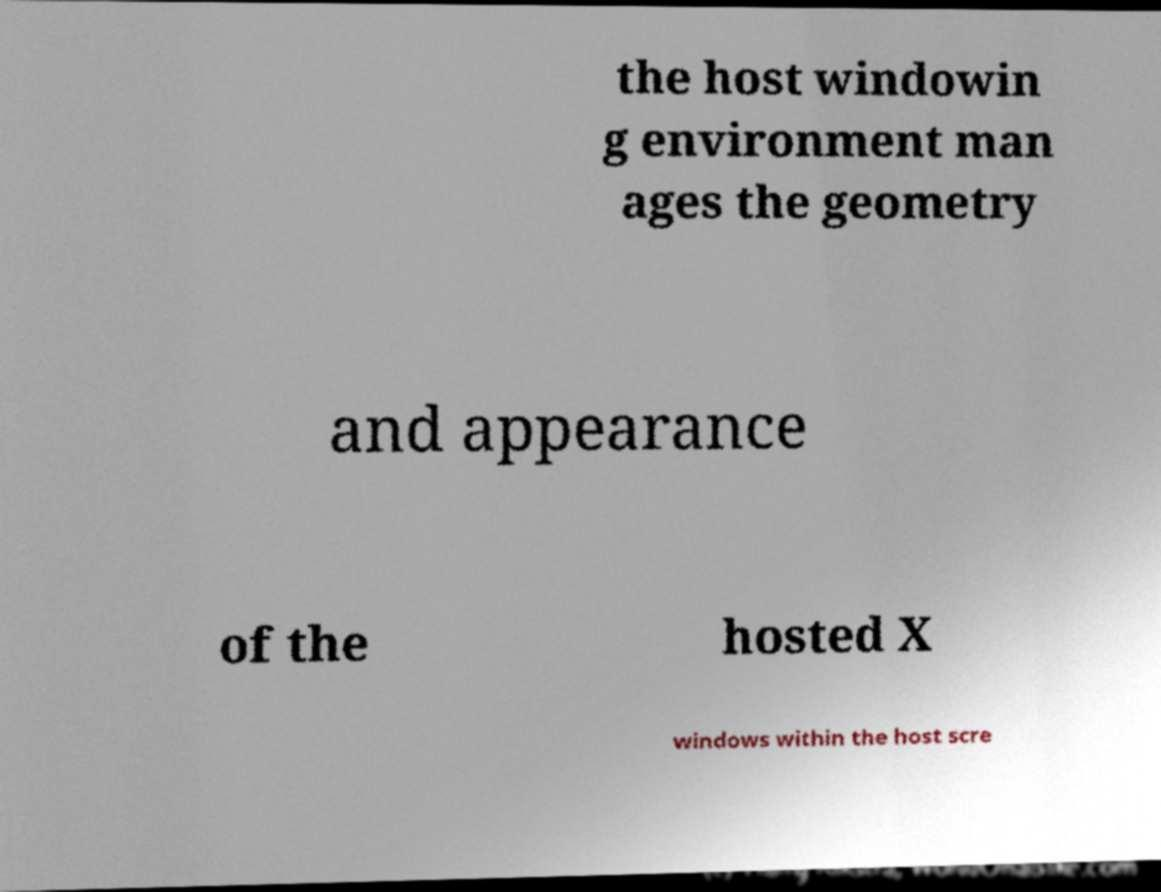Could you assist in decoding the text presented in this image and type it out clearly? the host windowin g environment man ages the geometry and appearance of the hosted X windows within the host scre 